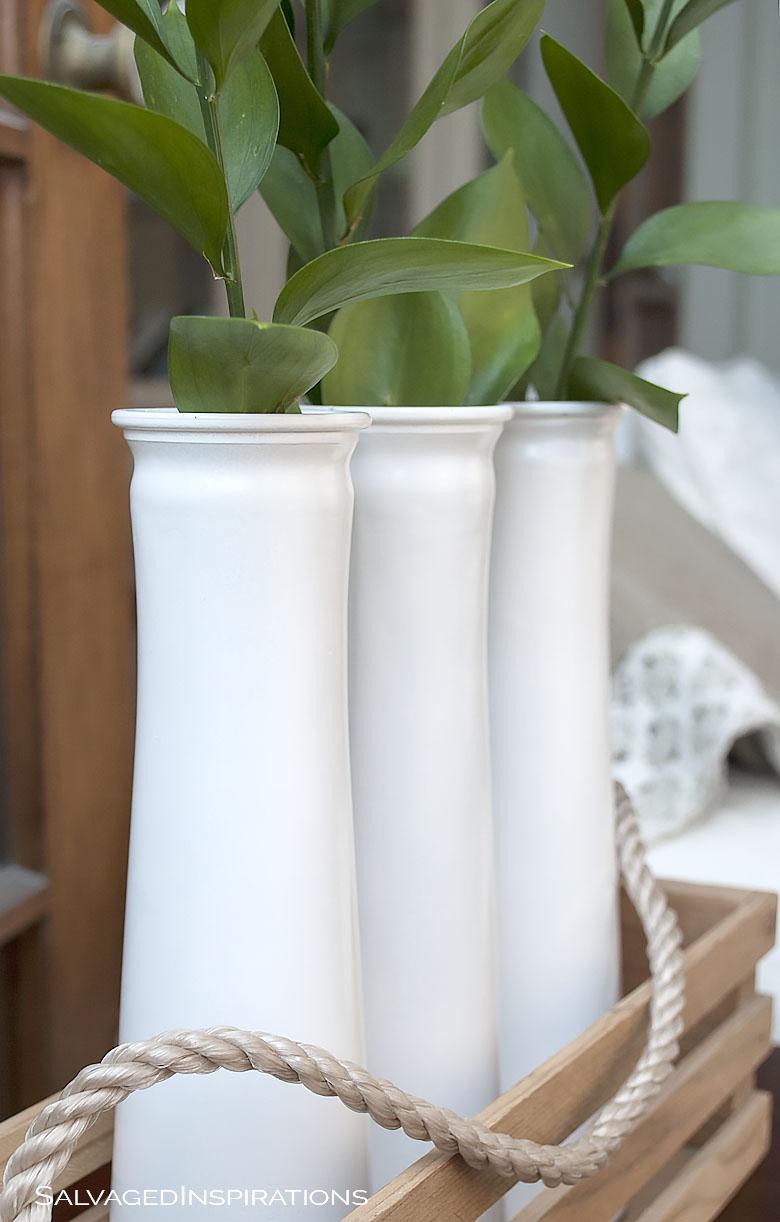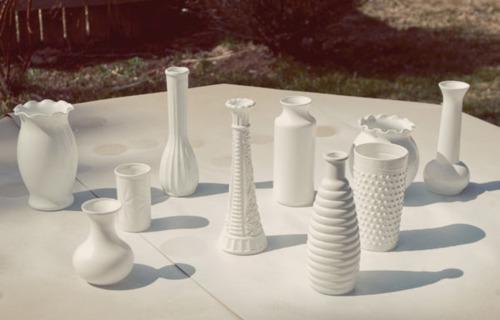The first image is the image on the left, the second image is the image on the right. Examine the images to the left and right. Is the description "In one image, a display of milk glass shows a squat pumpkin-shaped piece in front of one shaped like an urn." accurate? Answer yes or no. No. 